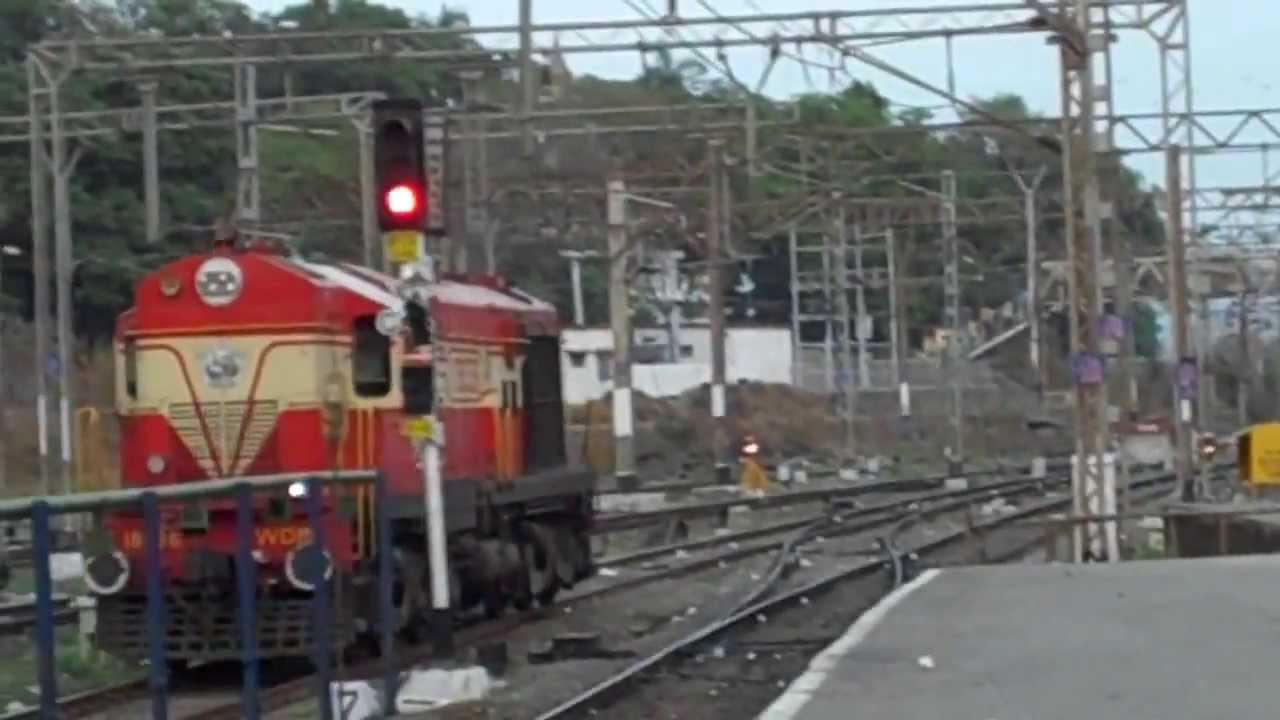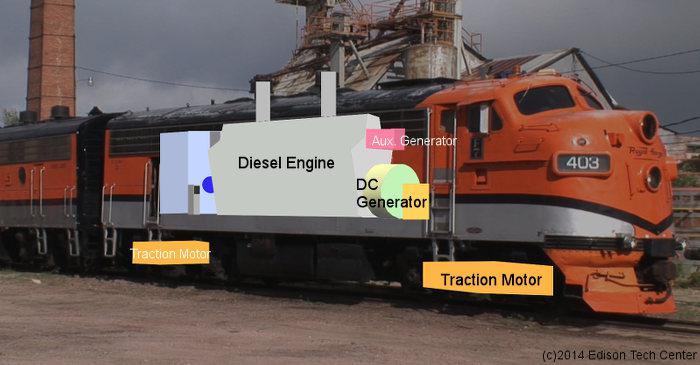The first image is the image on the left, the second image is the image on the right. Examine the images to the left and right. Is the description "The train in the image on the right has grates covering its front windows." accurate? Answer yes or no. No. 